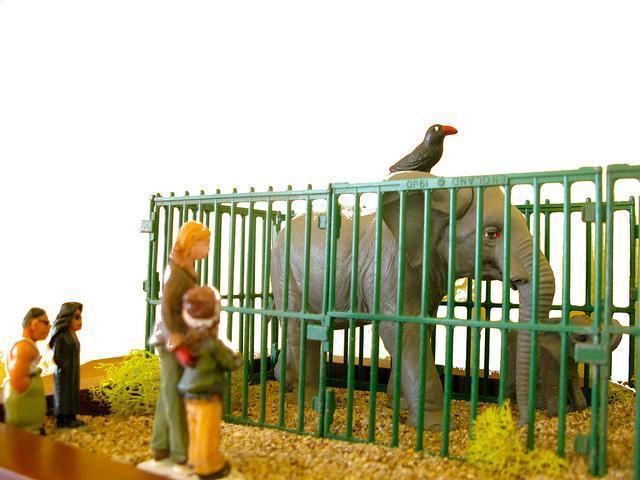Is the statement "The elephant is beneath the bird." accurate regarding the image?
Answer yes or no. Yes. Is the caption "The bird is far from the elephant." a true representation of the image?
Answer yes or no. No. 